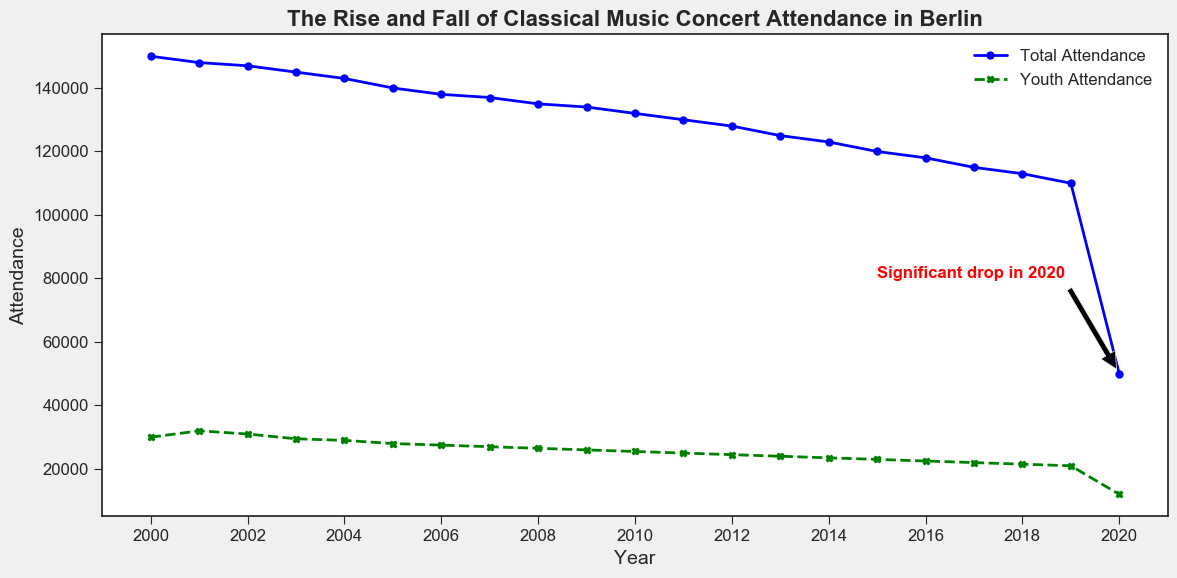what happened in 2020 to the classical music concert attendance in Berlin? In 2020, both total attendance and youth attendance saw a significant drop, which is visually indicated by the annotation pointing to 2020. The total attendance dropped to 50,000, and the youth attendance dropped to 12,000. The annotation highlights this dramatic decline.
Answer: Significant drop By how much did the total attendance decrease from 2019 to 2020? The total attendance in 2019 was 110,000, and it dropped to 50,000 in 2020. The decrease can be calculated by subtracting the 2020 value from the 2019 value: 110,000 - 50,000 = 60,000.
Answer: 60,000 Which year had the highest youth attendance? The highest youth attendance can be identified by comparing all the values on the green dashed line. The highest value of 32,000 occurs in 2001.
Answer: 2001 What is the difference between total attendance and youth attendance in 2005? In 2005, the total attendance was 140,000 and the youth attendance was 28,000. The difference is calculated by subtracting the youth attendance from the total attendance: 140,000 - 28,000 = 112,000.
Answer: 112,000 Which segment of the attendance saw a steady annual decrease from 2000 to 2019? Both the total attendance (blue line) and youth attendance (green dashed line) show a steady annual decrease from 2000 to 2019. This gradual decline is consistent across all the years except the anomalous drop in 2020.
Answer: Both Has the youth attendance ever been more than 25% of the total attendance? To determine if youth attendance has ever been more than 25% of the total attendance, we can compare each year's youth attendance to 25% of the total attendance for that year. From the data, the total attendance in 2000 was 150,000 and 25% of that is 37,500. The youth attendance that year was 30,000, which is less than 37,500. Checking other years similarly, youth attendance never exceeds 25% of total attendance.
Answer: No In which year did classical music concert attendance see the most stable youth attendance of around 25,000? We look for the years where the youth attendance hovers around 25,000, which are 2010, 2011, and 2012. These years had values closest to 25,000 with 25,500, 25,000, and 24,500 respectively, demonstrating the most stability around 25,000.
Answer: 2010-2012 What is the average total attendance from 2000 to 2019? To find the average total attendance, sum the total attendance from each year from 2000 to 2019 and divide by the number of years. The sum is 2,502,000 (calculated from adding each year's value) and dividing it by 20 gives: 2,502,000 / 20 = 125,100.
Answer: 125,100 How does the total attendance in 2020 compare visually to the rest of the years? The total attendance in 2020, marked by a sharp drop to 50,000, is visually represented as much lower than in any other year, clearly indicated by the annotation as well. This steep decline contrasts strikingly with the more gradual decreases in previous years.
Answer: Much lower 